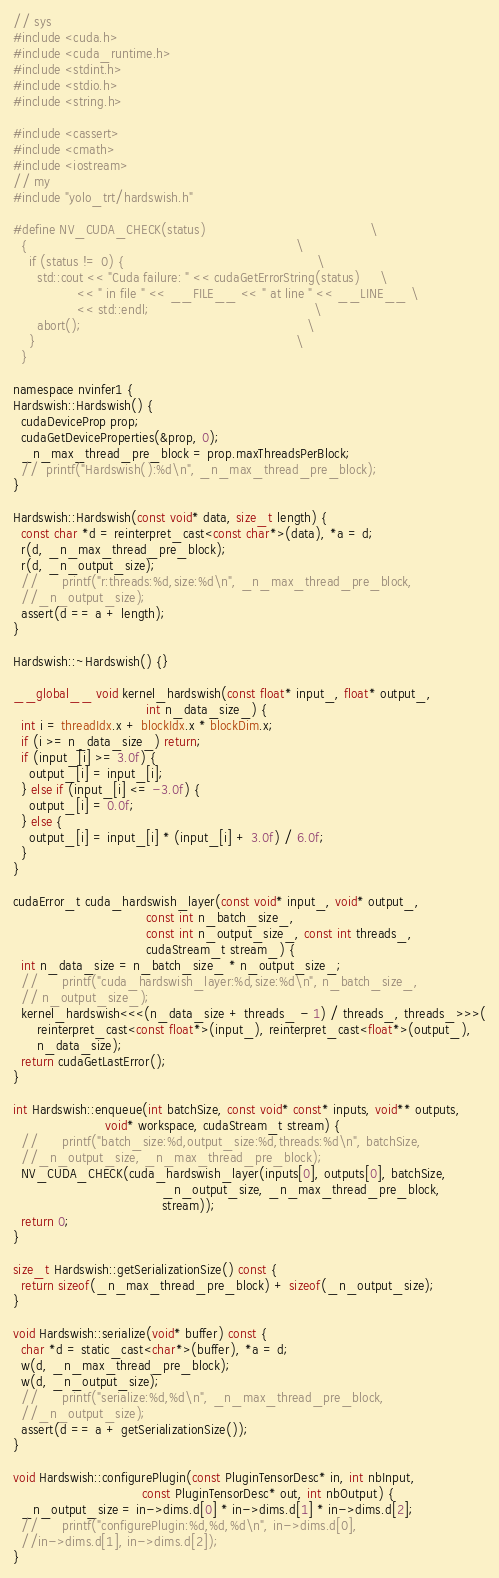Convert code to text. <code><loc_0><loc_0><loc_500><loc_500><_Cuda_>// sys
#include <cuda.h>
#include <cuda_runtime.h>
#include <stdint.h>
#include <stdio.h>
#include <string.h>

#include <cassert>
#include <cmath>
#include <iostream>
// my
#include "yolo_trt/hardswish.h"

#define NV_CUDA_CHECK(status)                                         \
  {                                                                   \
    if (status != 0) {                                                \
      std::cout << "Cuda failure: " << cudaGetErrorString(status)     \
                << " in file " << __FILE__ << " at line " << __LINE__ \
                << std::endl;                                         \
      abort();                                                        \
    }                                                                 \
  }

namespace nvinfer1 {
Hardswish::Hardswish() {
  cudaDeviceProp prop;
  cudaGetDeviceProperties(&prop, 0);
  _n_max_thread_pre_block = prop.maxThreadsPerBlock;
  //	printf("Hardswish():%d\n", _n_max_thread_pre_block);
}

Hardswish::Hardswish(const void* data, size_t length) {
  const char *d = reinterpret_cast<const char*>(data), *a = d;
  r(d, _n_max_thread_pre_block);
  r(d, _n_output_size);
  //		printf("r:threads:%d,size:%d\n", _n_max_thread_pre_block,
  //_n_output_size);
  assert(d == a + length);
}

Hardswish::~Hardswish() {}

__global__ void kernel_hardswish(const float* input_, float* output_,
                                 int n_data_size_) {
  int i = threadIdx.x + blockIdx.x * blockDim.x;
  if (i >= n_data_size_) return;
  if (input_[i] >= 3.0f) {
    output_[i] = input_[i];
  } else if (input_[i] <= -3.0f) {
    output_[i] = 0.0f;
  } else {
    output_[i] = input_[i] * (input_[i] + 3.0f) / 6.0f;
  }
}

cudaError_t cuda_hardswish_layer(const void* input_, void* output_,
                                 const int n_batch_size_,
                                 const int n_output_size_, const int threads_,
                                 cudaStream_t stream_) {
  int n_data_size = n_batch_size_ * n_output_size_;
  //		printf("cuda_hardswish_layer:%d,size:%d\n", n_batch_size_,
  // n_output_size_);
  kernel_hardswish<<<(n_data_size + threads_ - 1) / threads_, threads_>>>(
      reinterpret_cast<const float*>(input_), reinterpret_cast<float*>(output_),
      n_data_size);
  return cudaGetLastError();
}

int Hardswish::enqueue(int batchSize, const void* const* inputs, void** outputs,
                       void* workspace, cudaStream_t stream) {
  //		printf("batch_size:%d,output_size:%d,threads:%d\n", batchSize,
  //_n_output_size, _n_max_thread_pre_block);
  NV_CUDA_CHECK(cuda_hardswish_layer(inputs[0], outputs[0], batchSize,
                                     _n_output_size, _n_max_thread_pre_block,
                                     stream));
  return 0;
}

size_t Hardswish::getSerializationSize() const {
  return sizeof(_n_max_thread_pre_block) + sizeof(_n_output_size);
}

void Hardswish::serialize(void* buffer) const {
  char *d = static_cast<char*>(buffer), *a = d;
  w(d, _n_max_thread_pre_block);
  w(d, _n_output_size);
  //		printf("serialize:%d,%d\n", _n_max_thread_pre_block,
  //_n_output_size);
  assert(d == a + getSerializationSize());
}

void Hardswish::configurePlugin(const PluginTensorDesc* in, int nbInput,
                                const PluginTensorDesc* out, int nbOutput) {
  _n_output_size = in->dims.d[0] * in->dims.d[1] * in->dims.d[2];
  //		printf("configurePlugin:%d,%d,%d\n", in->dims.d[0],
  //in->dims.d[1], in->dims.d[2]);
}</code> 